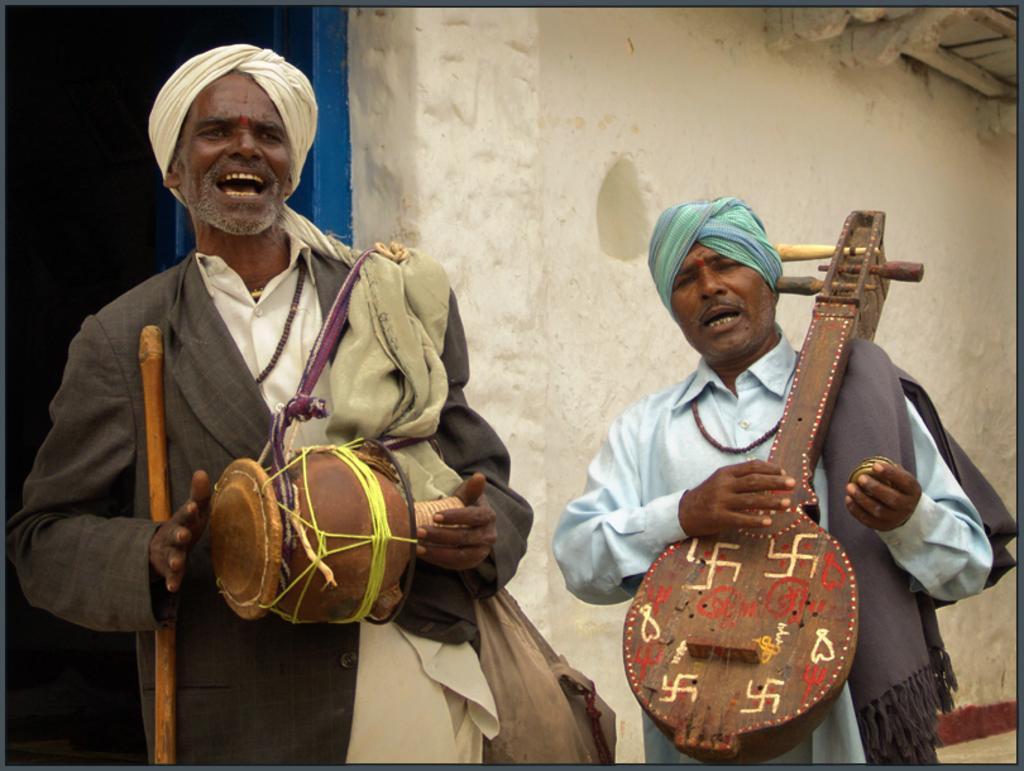In one or two sentences, can you explain what this image depicts? There are two men standing, holding and playing musical instruments, and singing. In the background, there is a white color wall, blue color door and a roof. 